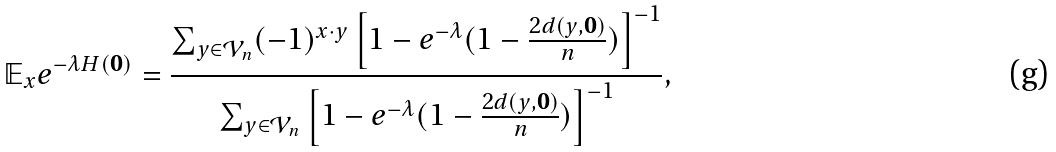<formula> <loc_0><loc_0><loc_500><loc_500>\mathbb { E } _ { x } e ^ { - \lambda H ( \boldsymbol 0 ) } = \frac { \sum _ { y \in \mathcal { V } _ { n } } ( - 1 ) ^ { x \cdot y } \left [ 1 - e ^ { - \lambda } ( 1 - \frac { 2 d ( y , \boldsymbol 0 ) } { n } ) \right ] ^ { - 1 } } { \sum _ { y \in \mathcal { V } _ { n } } \left [ 1 - e ^ { - \lambda } ( 1 - \frac { 2 d ( y , \boldsymbol 0 ) } { n } ) \right ] ^ { - 1 } } ,</formula> 